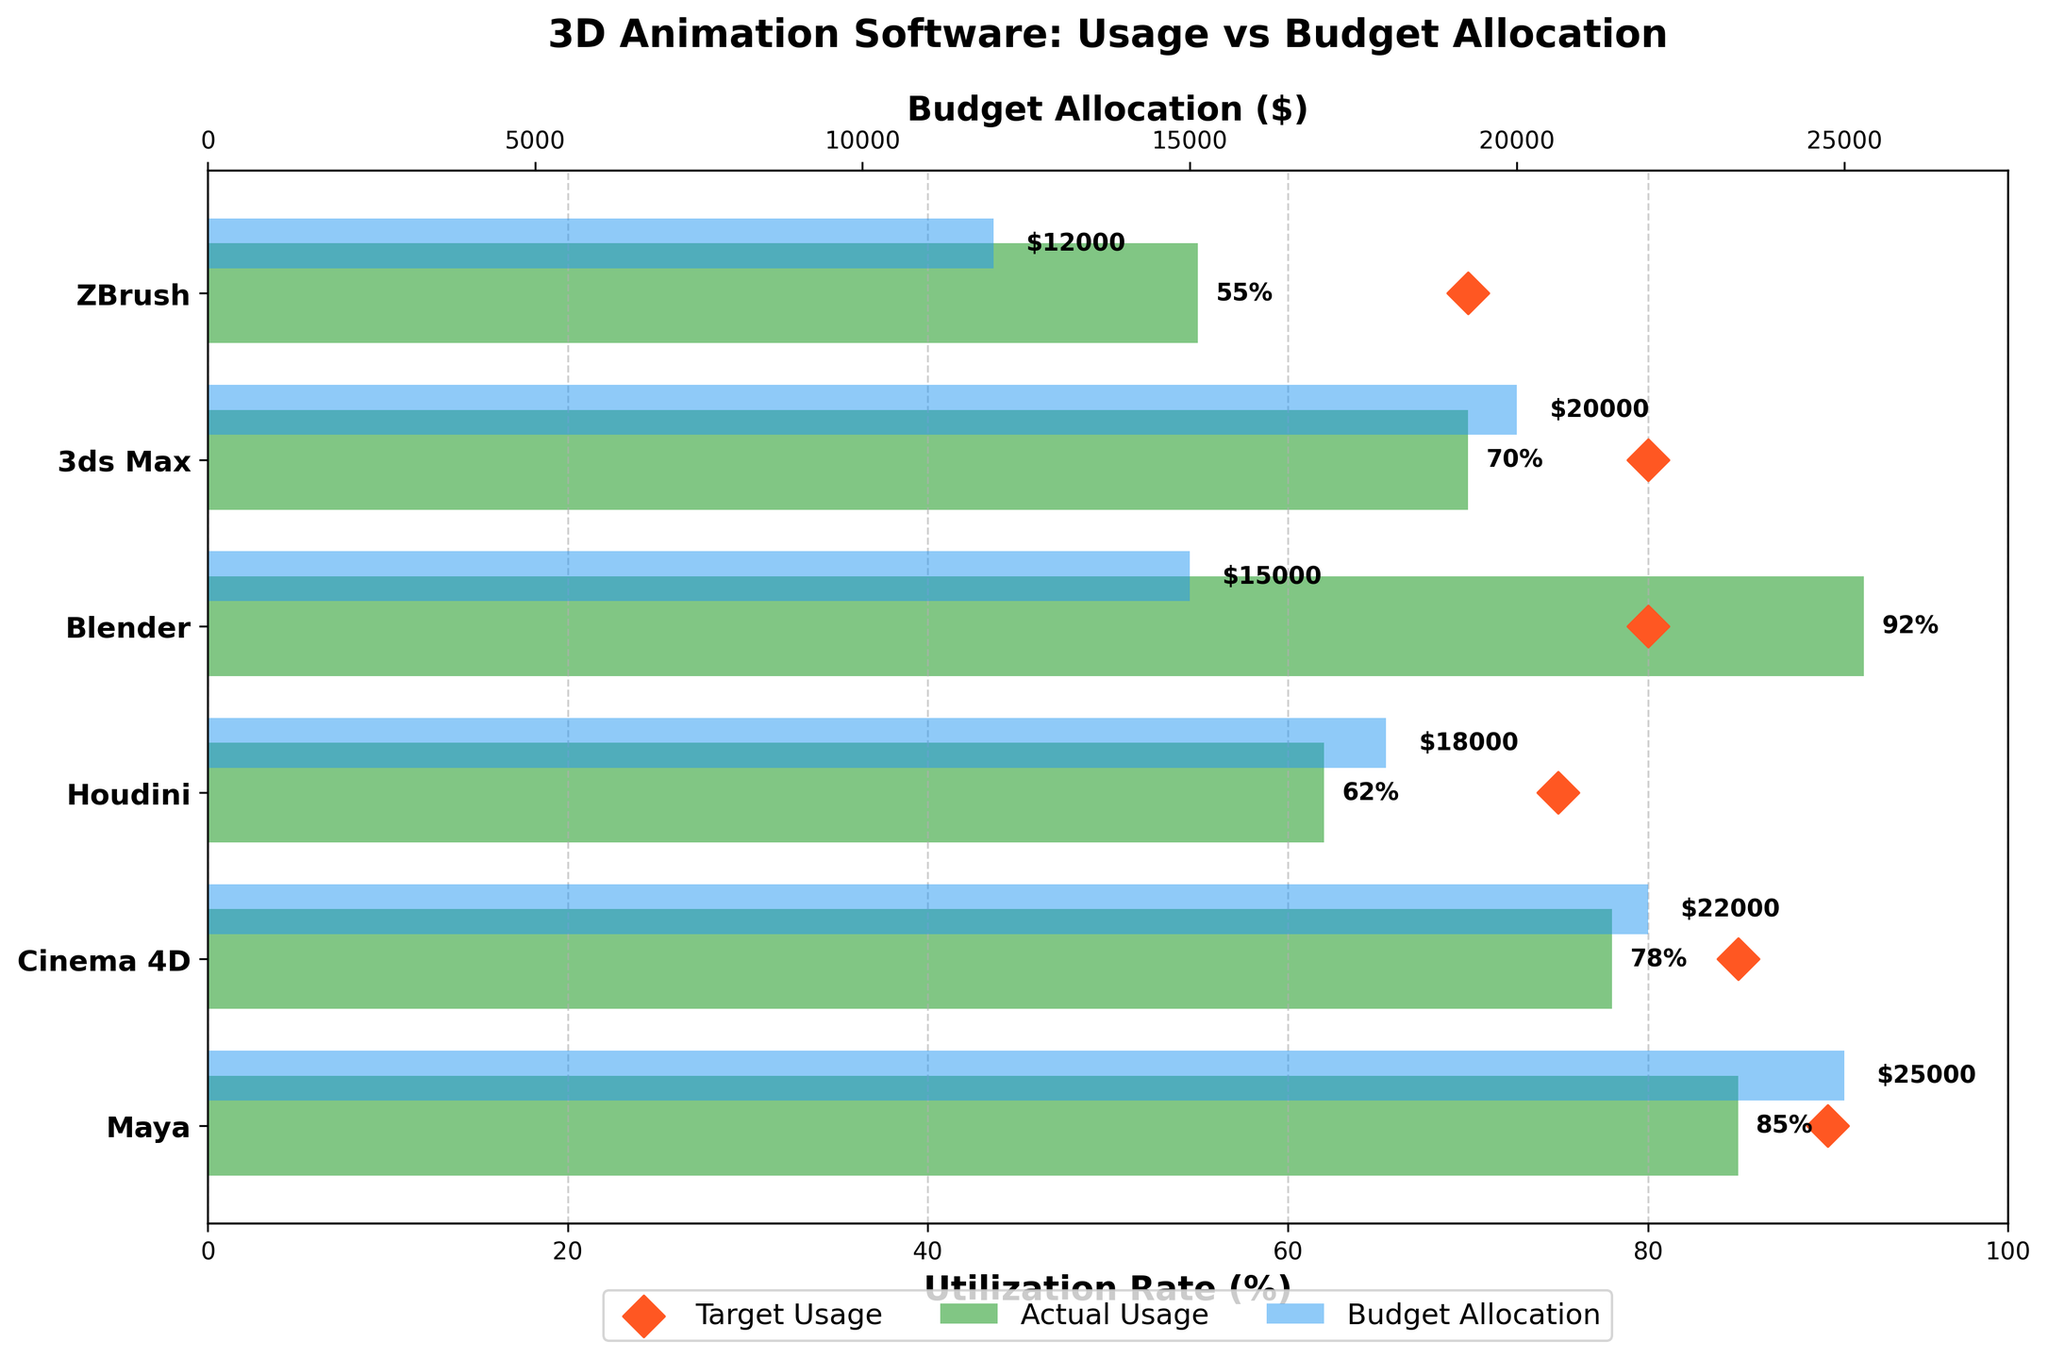What's the actual usage rate of Blender? The actual usage rate of Blender is indicated by the green bar's length on the horizontal axis corresponding to Blender.
Answer: 92% What software has the highest budget allocation? To determine this, look for the longest blue budget allocation bar. Maya has the longest blue bar.
Answer: Maya How much higher is Blender's actual usage rate compared to its target usage rate? Blender's actual usage rate is 92%, and its target usage rate is 80%. To find the difference, subtract 80 from 92.
Answer: 12% Among the software tools shown, which one has the lowest actual usage rate? The lowest actual usage rate is represented by the shortest green bar. ZBrush has the shortest green bar.
Answer: ZBrush Is Maya meeting its target usage rate? Maya's actual usage rate is 85%, and its target usage rate is 90%. To determine if it's meeting the target, compare these values.
Answer: No Which software has the smallest gap between actual and target usage rates? Calculate the difference between the actual and target usage rates for each software. Blender has a gap of 12%, Maya has 5%, Cinema 4D has 7%, Houdini has 13%, 3ds Max has 10%, and ZBrush has 15%. The smallest gap is for Maya.
Answer: Maya What is the total budget allocation for all the software tools? Sum the budget allocation values: $25000 (Maya) + $22000 (Cinema 4D) + $18000 (Houdini) + $15000 (Blender) + $20000 (3ds Max) + $12000 (ZBrush). This equals $112000.
Answer: $112000 Which software has the highest target usage rate, and what is that rate? Look for the highest red diamond marker on the x-axis. Maya has the highest target usage rate of 90%.
Answer: Maya; 90% For Cinema 4D, how much lower is its actual usage rate compared to its target usage rate? Cinema 4D's actual usage rate is 78%, and its target usage rate is 85%. Subtract the actual rate from the target rate: 85% - 78%.
Answer: 7% How does the actual usage rate of Houdini compare to that of 3ds Max? Houdini’s actual usage rate is 62%, while 3ds Max’s is 70%. Compare these two values.
Answer: Houdini is 8% lower than 3ds Max 